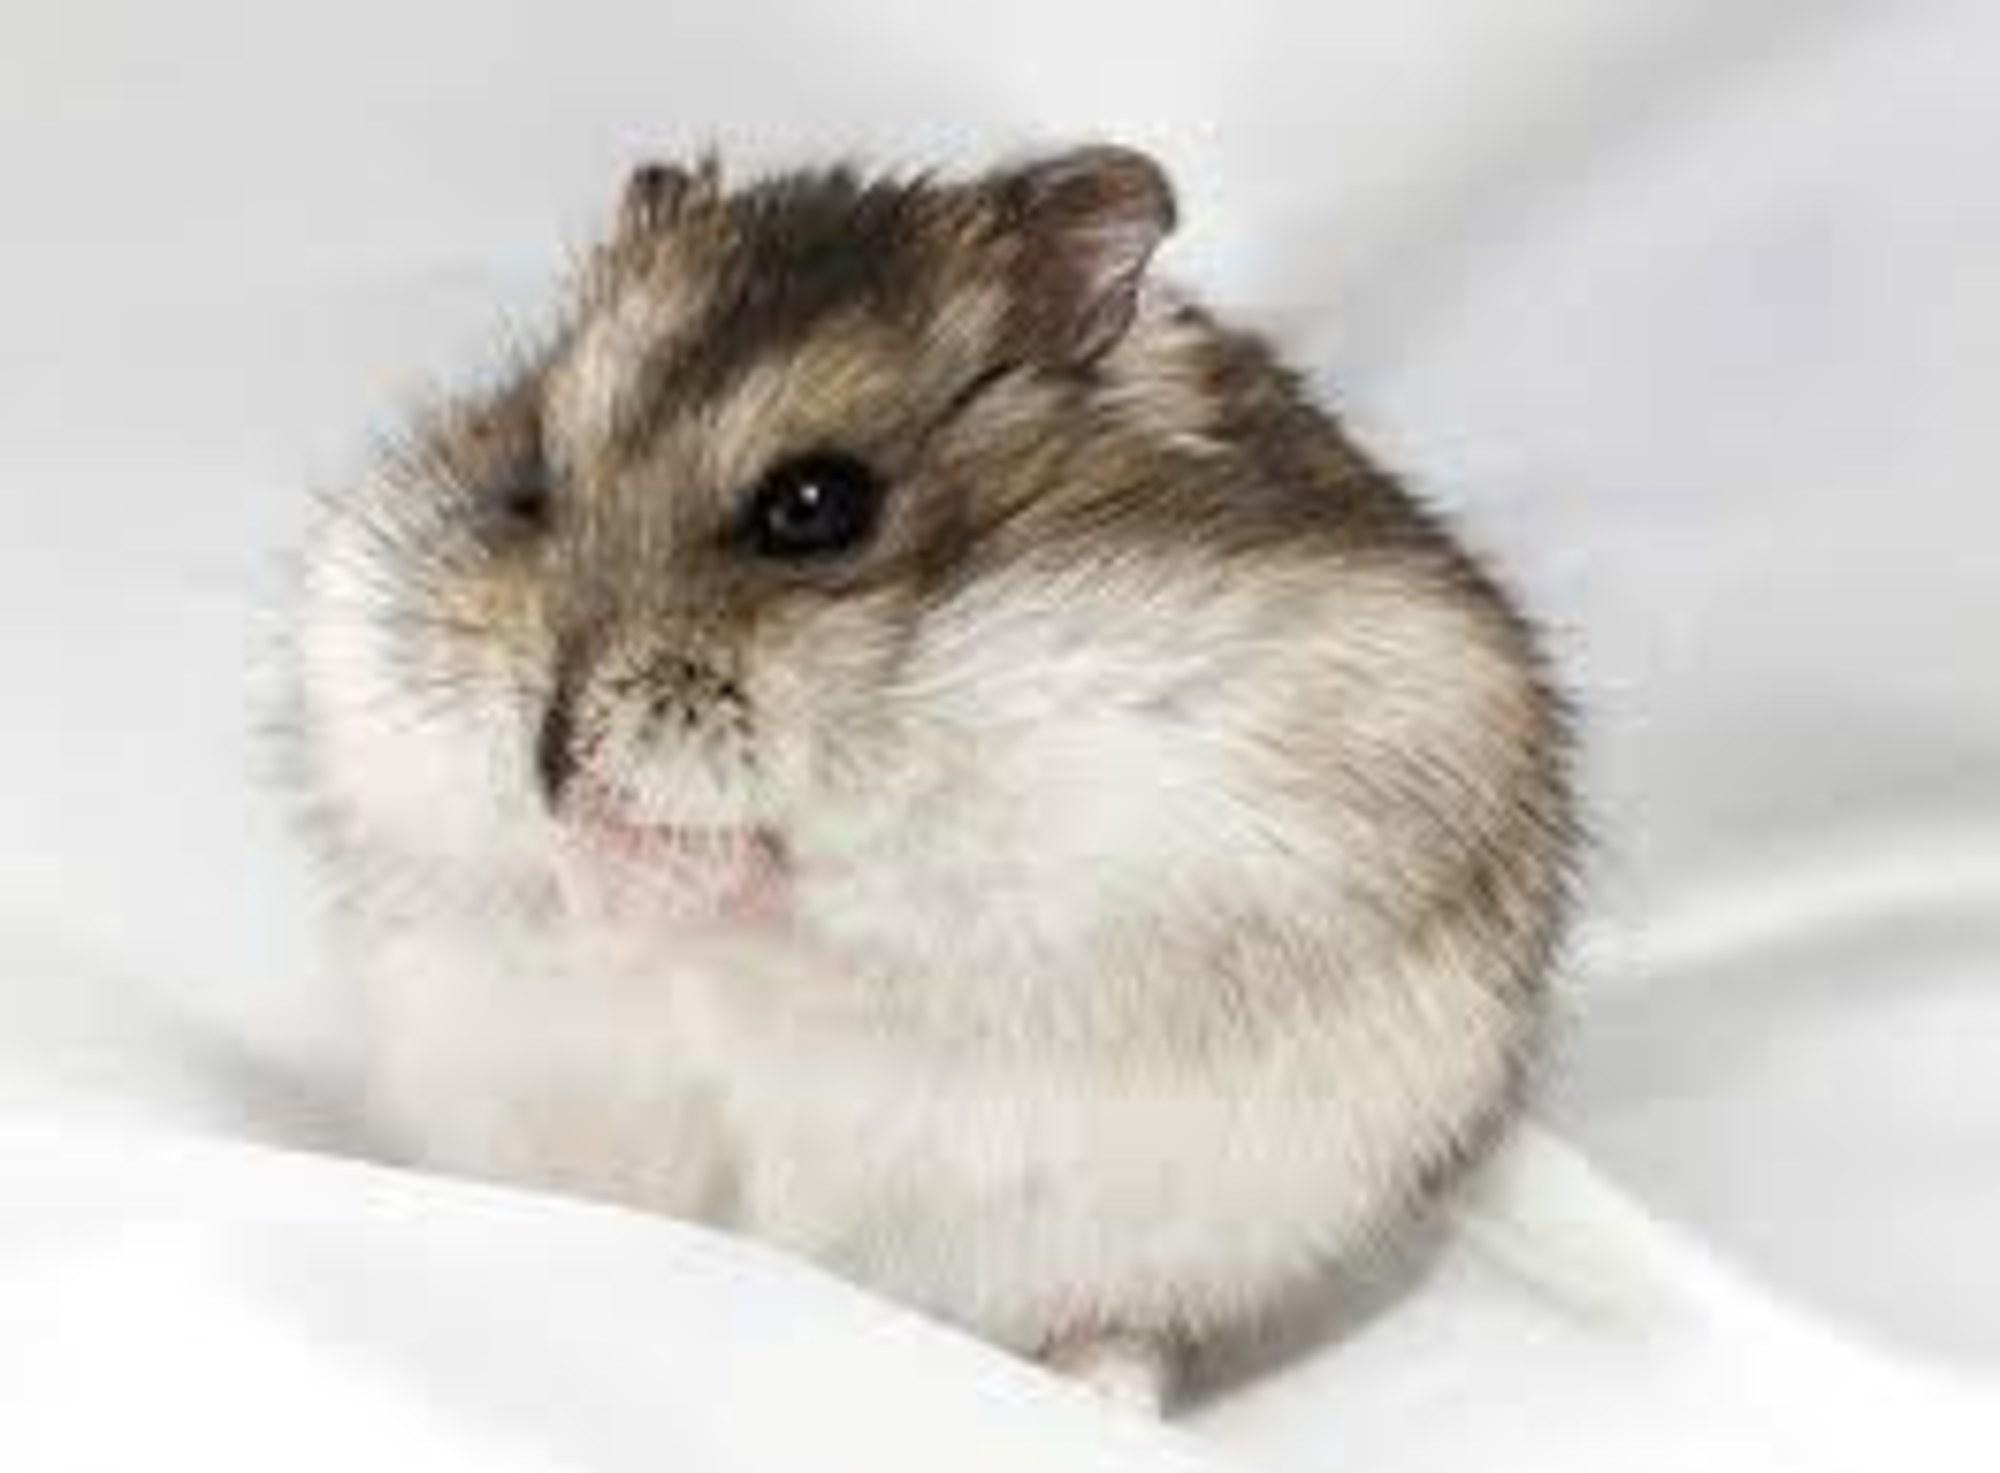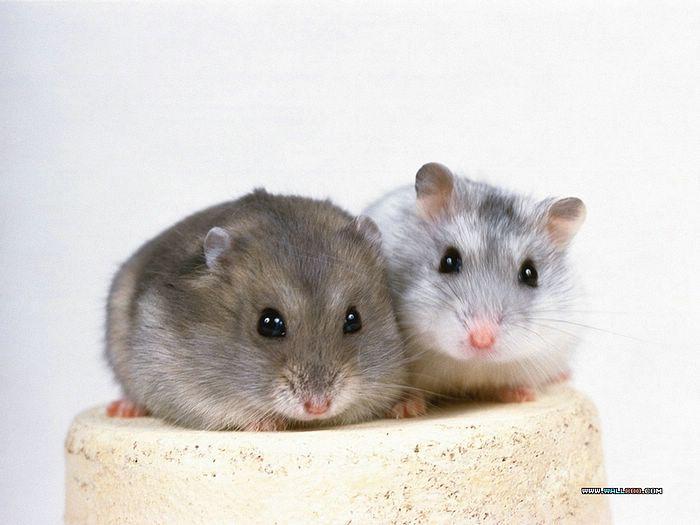The first image is the image on the left, the second image is the image on the right. For the images shown, is this caption "The rodents in the image on the left are face to face." true? Answer yes or no. No. The first image is the image on the left, the second image is the image on the right. Considering the images on both sides, is "Each image contains two pet rodents, and at least one image includes a rodent sitting upright." valid? Answer yes or no. No. 